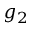<formula> <loc_0><loc_0><loc_500><loc_500>g _ { 2 }</formula> 